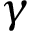<formula> <loc_0><loc_0><loc_500><loc_500>\gamma</formula> 